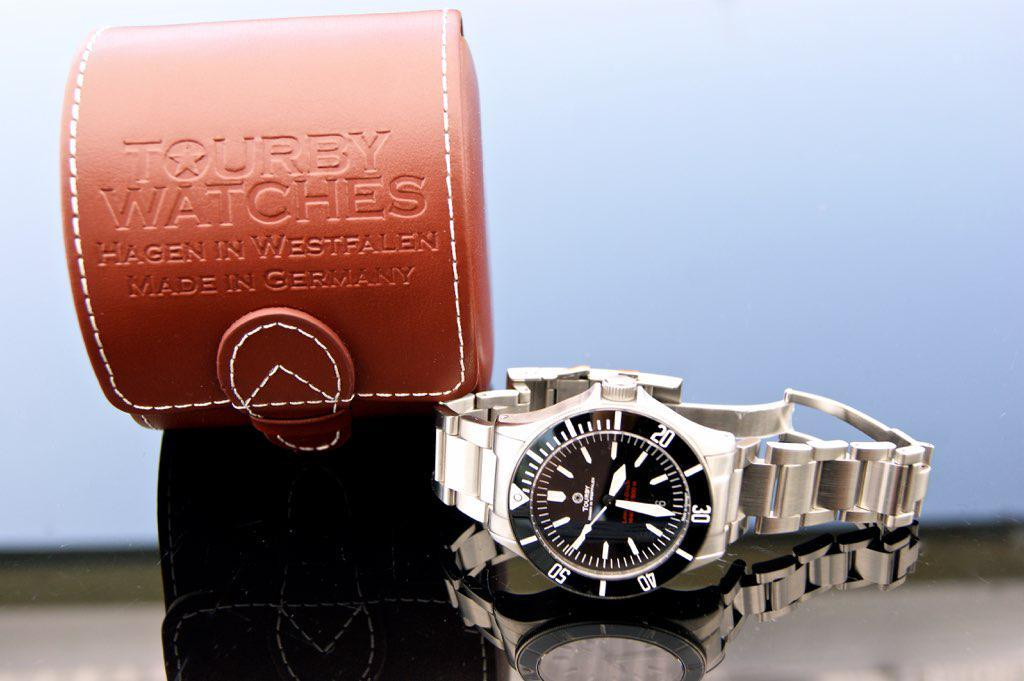Provide a one-sentence caption for the provided image. Watch laying on the side next to the Tourby Watch case. 